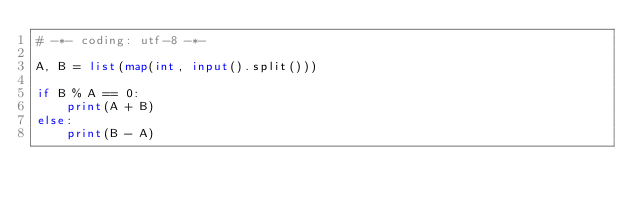Convert code to text. <code><loc_0><loc_0><loc_500><loc_500><_Python_># -*- coding: utf-8 -*-

A, B = list(map(int, input().split()))

if B % A == 0:
    print(A + B)
else:
    print(B - A)
</code> 